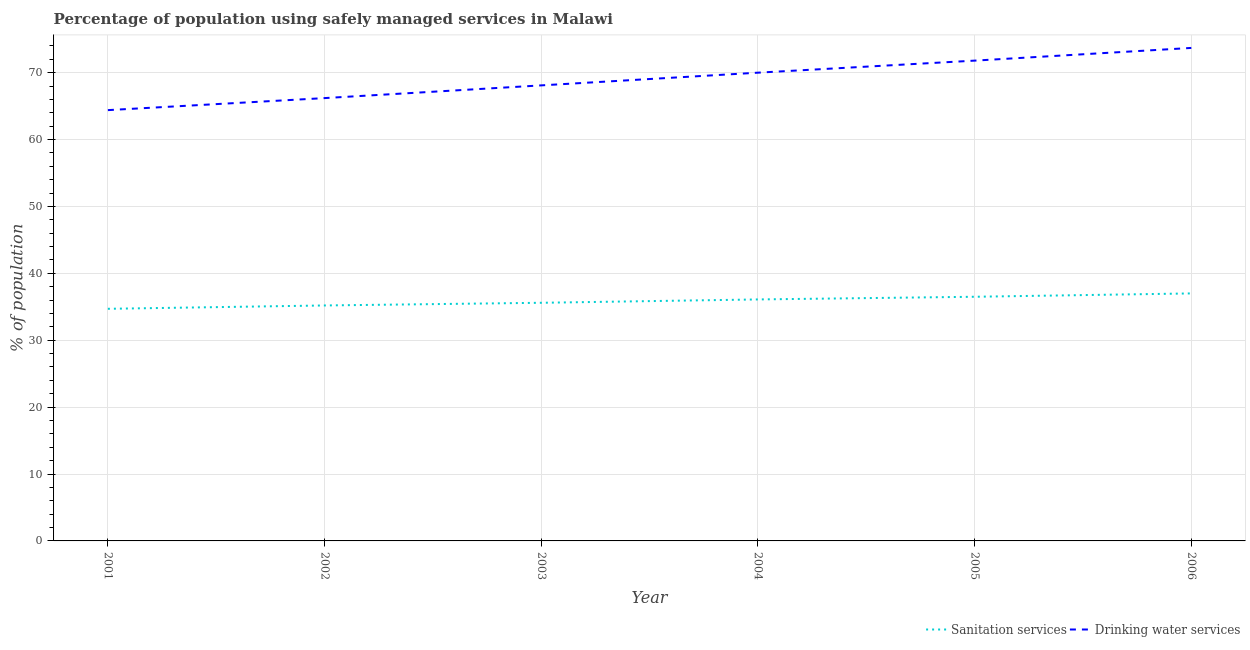What is the percentage of population who used drinking water services in 2005?
Provide a short and direct response. 71.8. Across all years, what is the maximum percentage of population who used sanitation services?
Your response must be concise. 37. Across all years, what is the minimum percentage of population who used sanitation services?
Give a very brief answer. 34.7. In which year was the percentage of population who used drinking water services minimum?
Your answer should be very brief. 2001. What is the total percentage of population who used drinking water services in the graph?
Offer a terse response. 414.2. What is the difference between the percentage of population who used sanitation services in 2002 and that in 2005?
Give a very brief answer. -1.3. What is the difference between the percentage of population who used drinking water services in 2004 and the percentage of population who used sanitation services in 2002?
Your answer should be very brief. 34.8. What is the average percentage of population who used drinking water services per year?
Offer a very short reply. 69.03. In the year 2001, what is the difference between the percentage of population who used drinking water services and percentage of population who used sanitation services?
Your answer should be compact. 29.7. What is the ratio of the percentage of population who used drinking water services in 2001 to that in 2005?
Give a very brief answer. 0.9. What is the difference between the highest and the lowest percentage of population who used drinking water services?
Offer a very short reply. 9.3. In how many years, is the percentage of population who used sanitation services greater than the average percentage of population who used sanitation services taken over all years?
Keep it short and to the point. 3. Is the percentage of population who used sanitation services strictly greater than the percentage of population who used drinking water services over the years?
Your answer should be very brief. No. Are the values on the major ticks of Y-axis written in scientific E-notation?
Your response must be concise. No. Does the graph contain any zero values?
Offer a very short reply. No. Does the graph contain grids?
Ensure brevity in your answer.  Yes. Where does the legend appear in the graph?
Offer a terse response. Bottom right. What is the title of the graph?
Give a very brief answer. Percentage of population using safely managed services in Malawi. What is the label or title of the Y-axis?
Your answer should be compact. % of population. What is the % of population in Sanitation services in 2001?
Offer a terse response. 34.7. What is the % of population in Drinking water services in 2001?
Keep it short and to the point. 64.4. What is the % of population of Sanitation services in 2002?
Offer a very short reply. 35.2. What is the % of population of Drinking water services in 2002?
Your response must be concise. 66.2. What is the % of population in Sanitation services in 2003?
Keep it short and to the point. 35.6. What is the % of population in Drinking water services in 2003?
Keep it short and to the point. 68.1. What is the % of population of Sanitation services in 2004?
Make the answer very short. 36.1. What is the % of population of Sanitation services in 2005?
Make the answer very short. 36.5. What is the % of population in Drinking water services in 2005?
Provide a short and direct response. 71.8. What is the % of population in Drinking water services in 2006?
Make the answer very short. 73.7. Across all years, what is the maximum % of population in Sanitation services?
Your answer should be compact. 37. Across all years, what is the maximum % of population in Drinking water services?
Provide a short and direct response. 73.7. Across all years, what is the minimum % of population in Sanitation services?
Make the answer very short. 34.7. Across all years, what is the minimum % of population in Drinking water services?
Give a very brief answer. 64.4. What is the total % of population in Sanitation services in the graph?
Your answer should be compact. 215.1. What is the total % of population of Drinking water services in the graph?
Your answer should be compact. 414.2. What is the difference between the % of population of Drinking water services in 2001 and that in 2002?
Offer a very short reply. -1.8. What is the difference between the % of population in Drinking water services in 2001 and that in 2004?
Provide a short and direct response. -5.6. What is the difference between the % of population of Drinking water services in 2001 and that in 2005?
Offer a very short reply. -7.4. What is the difference between the % of population of Sanitation services in 2001 and that in 2006?
Ensure brevity in your answer.  -2.3. What is the difference between the % of population of Drinking water services in 2002 and that in 2004?
Provide a short and direct response. -3.8. What is the difference between the % of population of Drinking water services in 2003 and that in 2004?
Ensure brevity in your answer.  -1.9. What is the difference between the % of population of Sanitation services in 2003 and that in 2005?
Offer a very short reply. -0.9. What is the difference between the % of population in Drinking water services in 2003 and that in 2006?
Offer a terse response. -5.6. What is the difference between the % of population in Sanitation services in 2004 and that in 2005?
Offer a very short reply. -0.4. What is the difference between the % of population of Drinking water services in 2004 and that in 2005?
Offer a very short reply. -1.8. What is the difference between the % of population in Drinking water services in 2004 and that in 2006?
Provide a short and direct response. -3.7. What is the difference between the % of population in Sanitation services in 2005 and that in 2006?
Your answer should be compact. -0.5. What is the difference between the % of population of Drinking water services in 2005 and that in 2006?
Keep it short and to the point. -1.9. What is the difference between the % of population of Sanitation services in 2001 and the % of population of Drinking water services in 2002?
Give a very brief answer. -31.5. What is the difference between the % of population in Sanitation services in 2001 and the % of population in Drinking water services in 2003?
Your answer should be very brief. -33.4. What is the difference between the % of population of Sanitation services in 2001 and the % of population of Drinking water services in 2004?
Make the answer very short. -35.3. What is the difference between the % of population in Sanitation services in 2001 and the % of population in Drinking water services in 2005?
Offer a terse response. -37.1. What is the difference between the % of population in Sanitation services in 2001 and the % of population in Drinking water services in 2006?
Provide a succinct answer. -39. What is the difference between the % of population in Sanitation services in 2002 and the % of population in Drinking water services in 2003?
Keep it short and to the point. -32.9. What is the difference between the % of population in Sanitation services in 2002 and the % of population in Drinking water services in 2004?
Make the answer very short. -34.8. What is the difference between the % of population in Sanitation services in 2002 and the % of population in Drinking water services in 2005?
Offer a very short reply. -36.6. What is the difference between the % of population of Sanitation services in 2002 and the % of population of Drinking water services in 2006?
Keep it short and to the point. -38.5. What is the difference between the % of population in Sanitation services in 2003 and the % of population in Drinking water services in 2004?
Offer a terse response. -34.4. What is the difference between the % of population of Sanitation services in 2003 and the % of population of Drinking water services in 2005?
Your answer should be very brief. -36.2. What is the difference between the % of population of Sanitation services in 2003 and the % of population of Drinking water services in 2006?
Provide a short and direct response. -38.1. What is the difference between the % of population of Sanitation services in 2004 and the % of population of Drinking water services in 2005?
Offer a terse response. -35.7. What is the difference between the % of population of Sanitation services in 2004 and the % of population of Drinking water services in 2006?
Make the answer very short. -37.6. What is the difference between the % of population of Sanitation services in 2005 and the % of population of Drinking water services in 2006?
Ensure brevity in your answer.  -37.2. What is the average % of population of Sanitation services per year?
Your response must be concise. 35.85. What is the average % of population of Drinking water services per year?
Keep it short and to the point. 69.03. In the year 2001, what is the difference between the % of population of Sanitation services and % of population of Drinking water services?
Ensure brevity in your answer.  -29.7. In the year 2002, what is the difference between the % of population in Sanitation services and % of population in Drinking water services?
Provide a succinct answer. -31. In the year 2003, what is the difference between the % of population of Sanitation services and % of population of Drinking water services?
Your answer should be compact. -32.5. In the year 2004, what is the difference between the % of population in Sanitation services and % of population in Drinking water services?
Offer a very short reply. -33.9. In the year 2005, what is the difference between the % of population in Sanitation services and % of population in Drinking water services?
Offer a terse response. -35.3. In the year 2006, what is the difference between the % of population of Sanitation services and % of population of Drinking water services?
Keep it short and to the point. -36.7. What is the ratio of the % of population of Sanitation services in 2001 to that in 2002?
Your answer should be compact. 0.99. What is the ratio of the % of population of Drinking water services in 2001 to that in 2002?
Keep it short and to the point. 0.97. What is the ratio of the % of population in Sanitation services in 2001 to that in 2003?
Offer a very short reply. 0.97. What is the ratio of the % of population of Drinking water services in 2001 to that in 2003?
Your answer should be compact. 0.95. What is the ratio of the % of population of Sanitation services in 2001 to that in 2004?
Keep it short and to the point. 0.96. What is the ratio of the % of population in Sanitation services in 2001 to that in 2005?
Give a very brief answer. 0.95. What is the ratio of the % of population of Drinking water services in 2001 to that in 2005?
Your answer should be very brief. 0.9. What is the ratio of the % of population of Sanitation services in 2001 to that in 2006?
Offer a very short reply. 0.94. What is the ratio of the % of population of Drinking water services in 2001 to that in 2006?
Provide a short and direct response. 0.87. What is the ratio of the % of population of Drinking water services in 2002 to that in 2003?
Keep it short and to the point. 0.97. What is the ratio of the % of population in Sanitation services in 2002 to that in 2004?
Make the answer very short. 0.98. What is the ratio of the % of population in Drinking water services in 2002 to that in 2004?
Your response must be concise. 0.95. What is the ratio of the % of population of Sanitation services in 2002 to that in 2005?
Your response must be concise. 0.96. What is the ratio of the % of population in Drinking water services in 2002 to that in 2005?
Provide a succinct answer. 0.92. What is the ratio of the % of population in Sanitation services in 2002 to that in 2006?
Offer a terse response. 0.95. What is the ratio of the % of population in Drinking water services in 2002 to that in 2006?
Make the answer very short. 0.9. What is the ratio of the % of population in Sanitation services in 2003 to that in 2004?
Ensure brevity in your answer.  0.99. What is the ratio of the % of population of Drinking water services in 2003 to that in 2004?
Offer a very short reply. 0.97. What is the ratio of the % of population in Sanitation services in 2003 to that in 2005?
Your response must be concise. 0.98. What is the ratio of the % of population of Drinking water services in 2003 to that in 2005?
Ensure brevity in your answer.  0.95. What is the ratio of the % of population in Sanitation services in 2003 to that in 2006?
Ensure brevity in your answer.  0.96. What is the ratio of the % of population of Drinking water services in 2003 to that in 2006?
Offer a terse response. 0.92. What is the ratio of the % of population of Sanitation services in 2004 to that in 2005?
Your answer should be very brief. 0.99. What is the ratio of the % of population in Drinking water services in 2004 to that in 2005?
Make the answer very short. 0.97. What is the ratio of the % of population of Sanitation services in 2004 to that in 2006?
Offer a terse response. 0.98. What is the ratio of the % of population in Drinking water services in 2004 to that in 2006?
Provide a succinct answer. 0.95. What is the ratio of the % of population of Sanitation services in 2005 to that in 2006?
Offer a terse response. 0.99. What is the ratio of the % of population in Drinking water services in 2005 to that in 2006?
Provide a succinct answer. 0.97. 